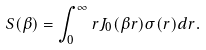<formula> <loc_0><loc_0><loc_500><loc_500>S ( \beta ) = \int _ { 0 } ^ { \infty } { r J _ { 0 } ( \beta r ) \sigma ( r ) d r } .</formula> 